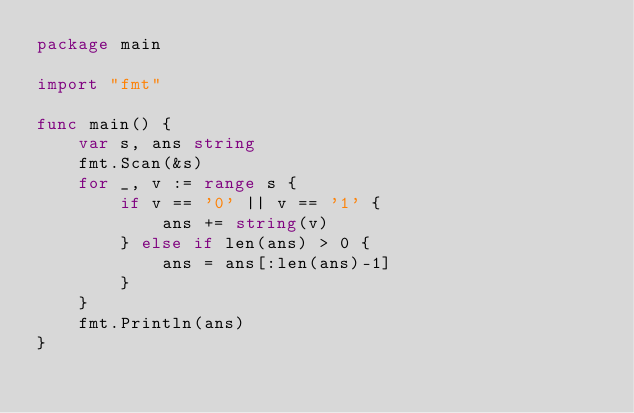<code> <loc_0><loc_0><loc_500><loc_500><_Go_>package main

import "fmt"

func main() {
	var s, ans string
	fmt.Scan(&s)
	for _, v := range s {
		if v == '0' || v == '1' {
			ans += string(v)
		} else if len(ans) > 0 {
			ans = ans[:len(ans)-1]
		}
	}
	fmt.Println(ans)
}</code> 